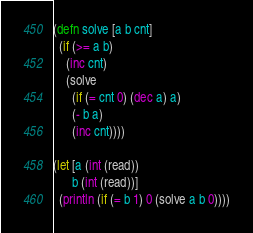Convert code to text. <code><loc_0><loc_0><loc_500><loc_500><_Clojure_>(defn solve [a b cnt]
  (if (>= a b)
    (inc cnt)
    (solve
      (if (= cnt 0) (dec a) a)
      (- b a)
      (inc cnt))))

(let [a (int (read))
      b (int (read))]
  (println (if (= b 1) 0 (solve a b 0))))
</code> 